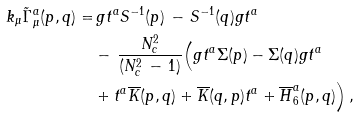Convert formula to latex. <formula><loc_0><loc_0><loc_500><loc_500>k _ { \mu } \tilde { \Gamma } ^ { a } _ { \mu } ( p , q ) = & \, g t ^ { a } S ^ { - 1 } ( p ) \, - \, S ^ { - 1 } ( q ) g t ^ { a } \, \\ & - \, \frac { N ^ { 2 } _ { c } } { ( N _ { c } ^ { 2 } \, - \, 1 ) } \Big { ( } g t ^ { a } \Sigma ( p ) - \Sigma ( q ) g t ^ { a } \, \quad \\ & + t ^ { a } \overline { K } ( p , q ) + \overline { K } ( q , p ) t ^ { a } + \overline { H } ^ { a } _ { 6 } ( p , q ) \Big { ) } \, ,</formula> 